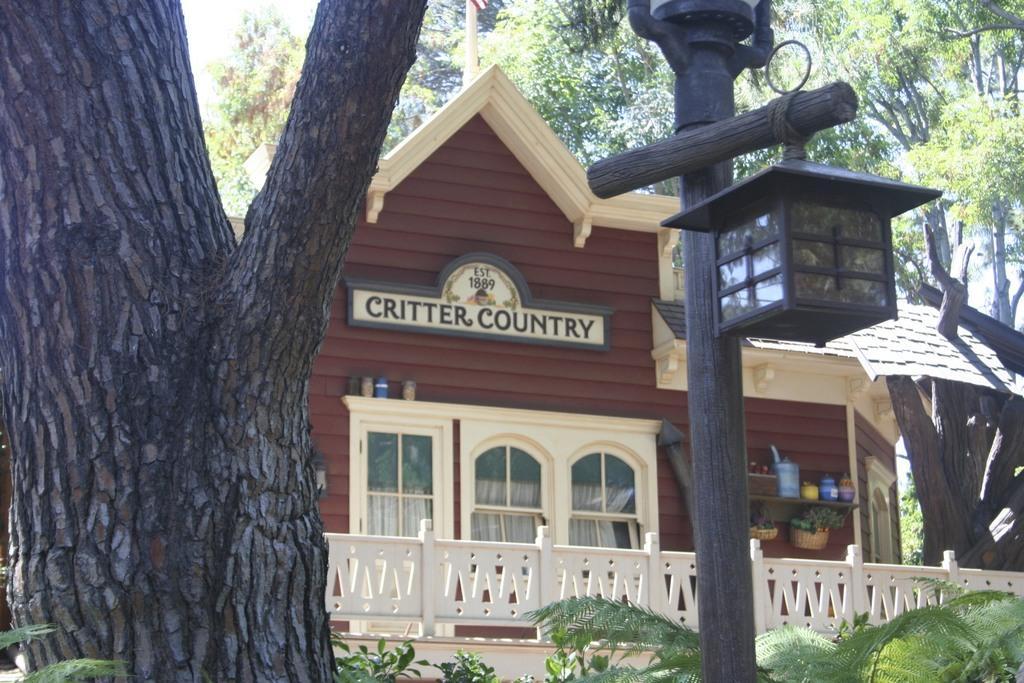How would you summarize this image in a sentence or two? In the center of the image we can see a house, wall, board, windows, shelves, bucket, basket, plants, railing and some other objects. In the background of the image we can see the trees, pole, light. 